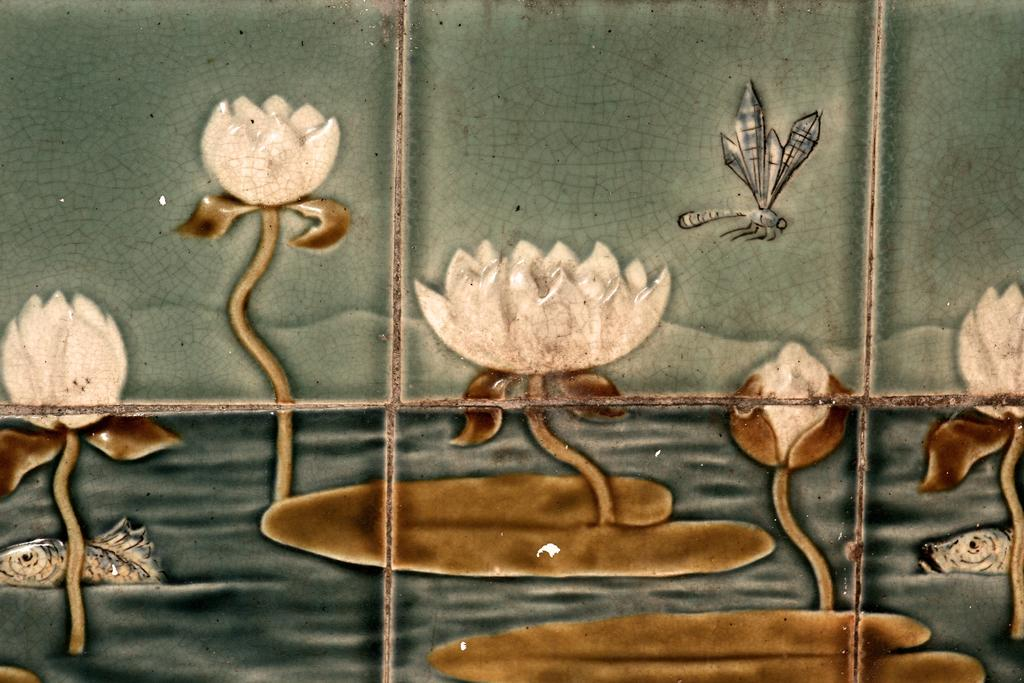What is the main subject of the painting in the image? The painting contains a painting of lotus flowers. How are the lotus flowers depicted in the painting? The painting depicts lotus leaves floating on the water. What other creatures can be seen in the painting? There are fishes and a dragonfly present in the painting. What type of loaf is being used as a chess piece in the painting? There is no loaf or chess piece present in the painting; it features lotus flowers, leaves, fishes, and a dragonfly. 